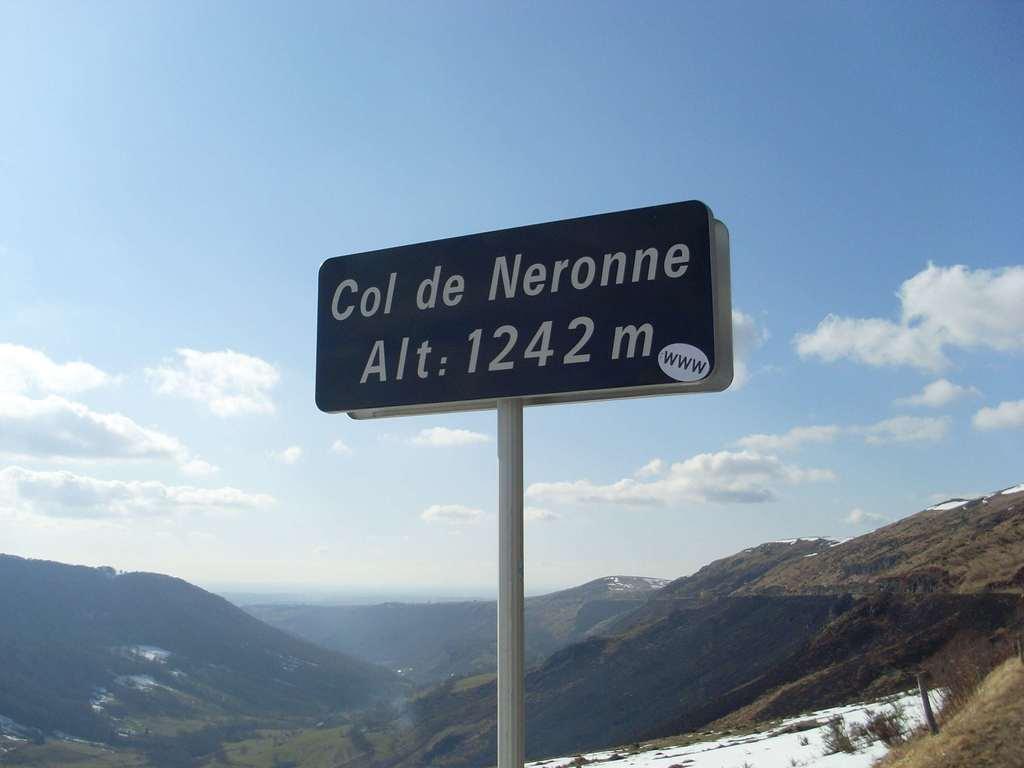Where is this according to the sign?
Give a very brief answer. Col de neronne. What is the altitude listed?
Your response must be concise. 1242 m. 